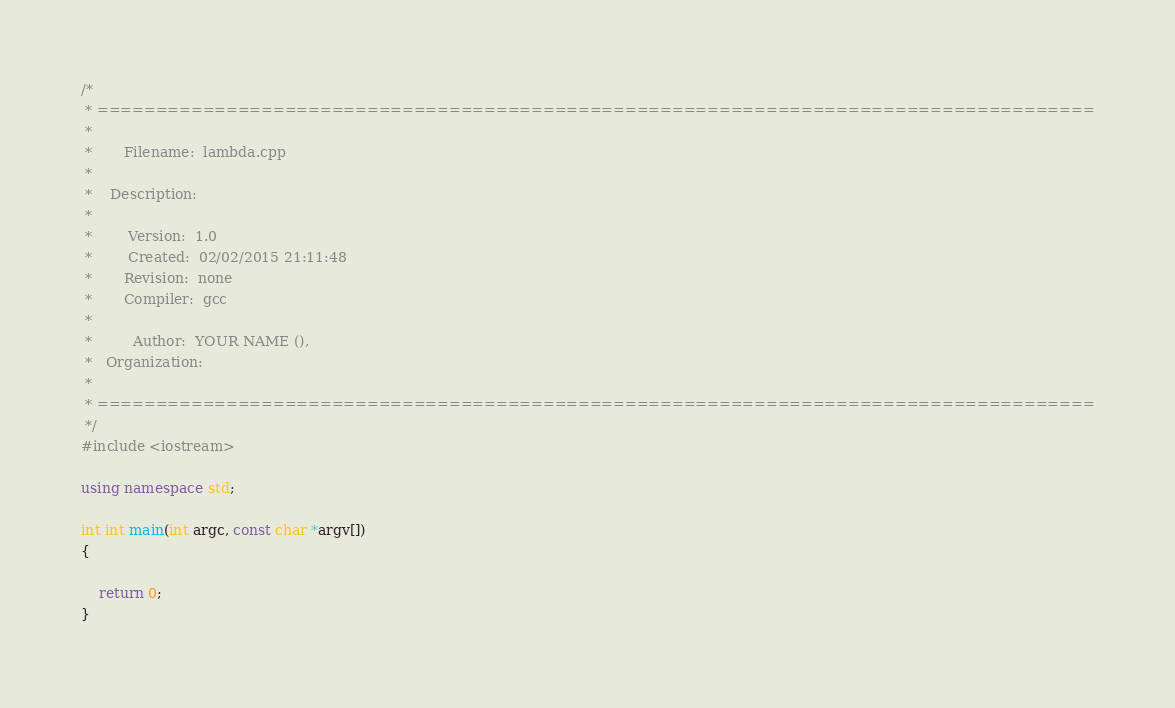Convert code to text. <code><loc_0><loc_0><loc_500><loc_500><_C++_>/*
 * =====================================================================================
 *
 *       Filename:  lambda.cpp
 *
 *    Description:  
 *
 *        Version:  1.0
 *        Created:  02/02/2015 21:11:48
 *       Revision:  none
 *       Compiler:  gcc
 *
 *         Author:  YOUR NAME (), 
 *   Organization:  
 *
 * =====================================================================================
 */
#include <iostream>

using namespace std;

int int main(int argc, const char *argv[])
{
    
    return 0;
}


</code> 